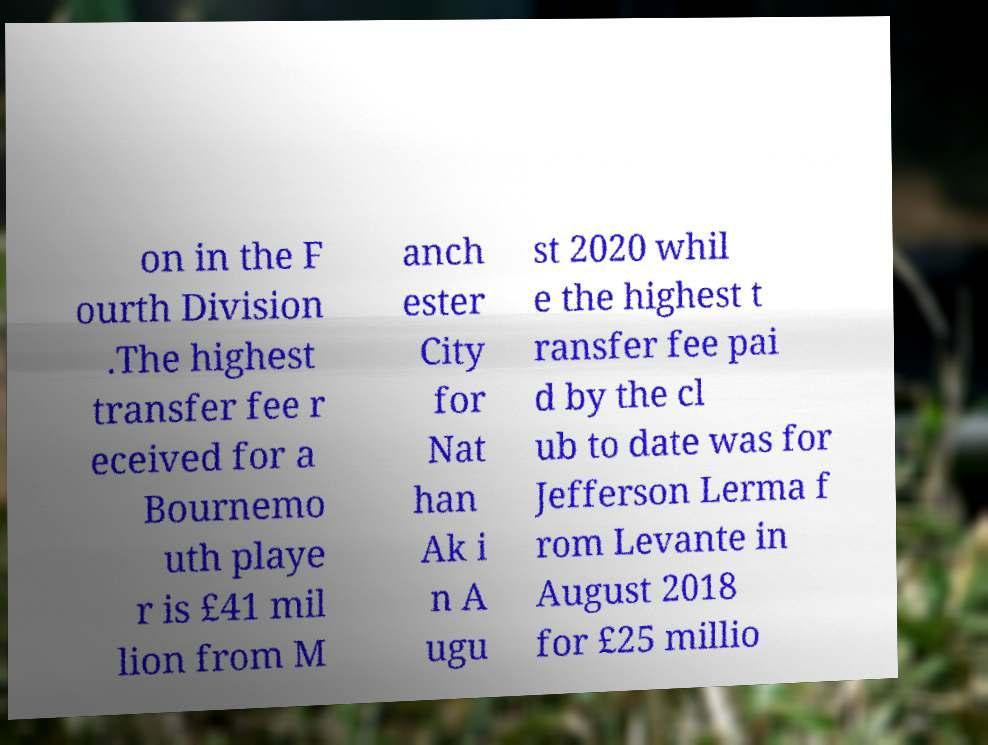There's text embedded in this image that I need extracted. Can you transcribe it verbatim? on in the F ourth Division .The highest transfer fee r eceived for a Bournemo uth playe r is £41 mil lion from M anch ester City for Nat han Ak i n A ugu st 2020 whil e the highest t ransfer fee pai d by the cl ub to date was for Jefferson Lerma f rom Levante in August 2018 for £25 millio 